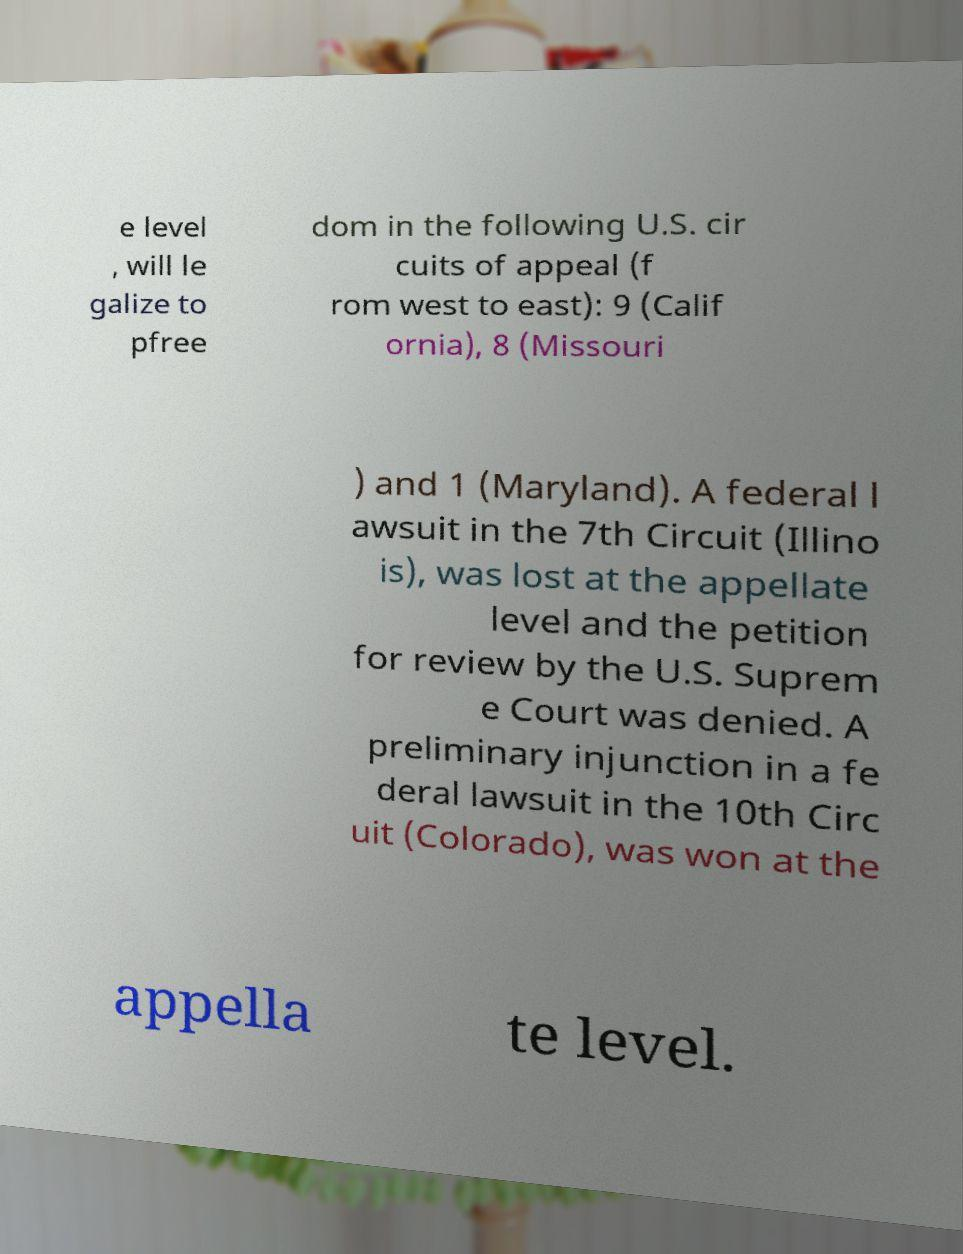Can you read and provide the text displayed in the image?This photo seems to have some interesting text. Can you extract and type it out for me? e level , will le galize to pfree dom in the following U.S. cir cuits of appeal (f rom west to east): 9 (Calif ornia), 8 (Missouri ) and 1 (Maryland). A federal l awsuit in the 7th Circuit (Illino is), was lost at the appellate level and the petition for review by the U.S. Suprem e Court was denied. A preliminary injunction in a fe deral lawsuit in the 10th Circ uit (Colorado), was won at the appella te level. 